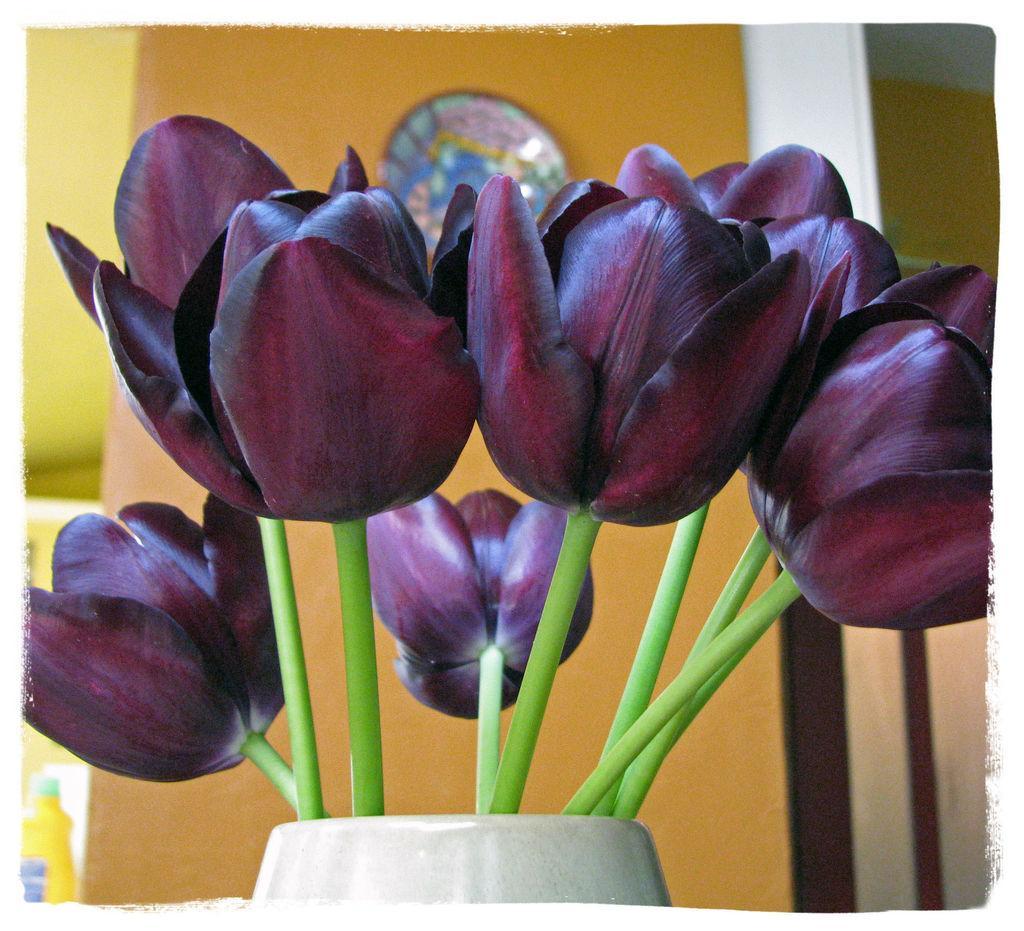Please provide a concise description of this image. In this image we can see one colorful object attached to the yellow wall, one white pot with beautiful flowers near to the yellow wall, and some objects are on the surface. 